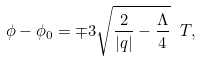<formula> <loc_0><loc_0><loc_500><loc_500>\phi - \phi _ { 0 } = \mp 3 \sqrt { \frac { 2 } { | q | } - \frac { \Lambda } { 4 } } \ T ,</formula> 